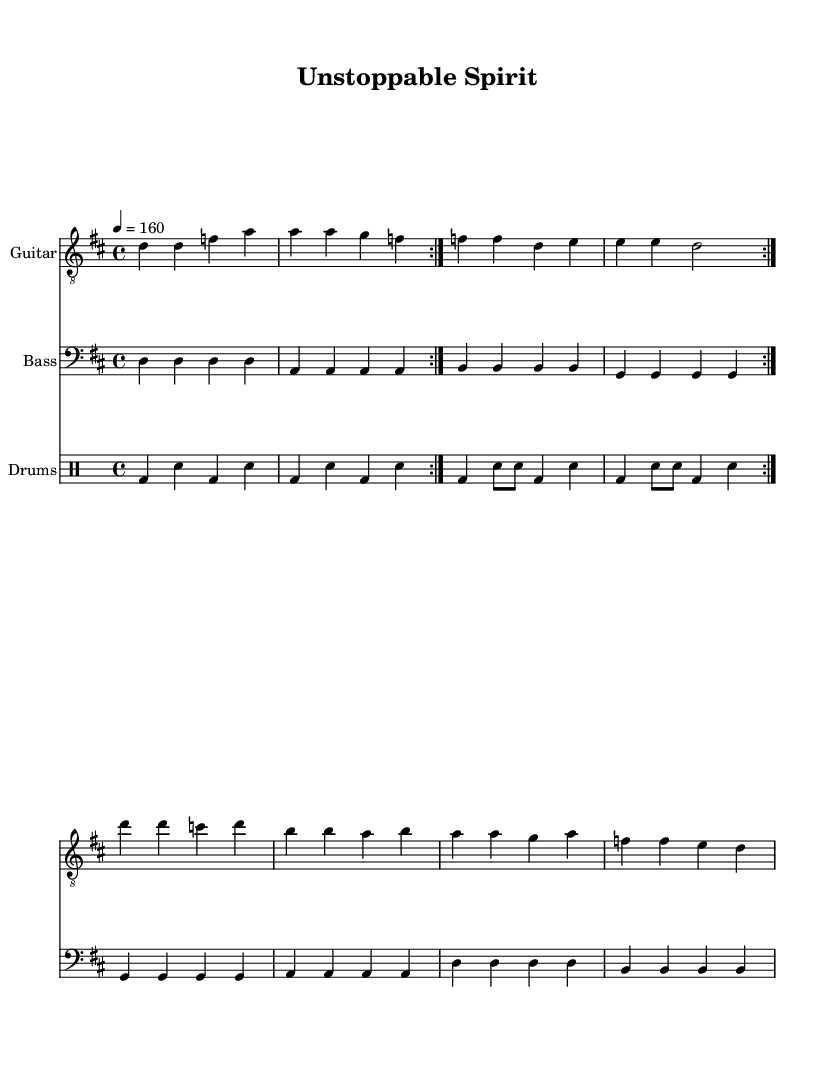What is the key signature of this music? The key signature is D major, indicated by two sharps (F# and C#).
Answer: D major What is the time signature of this music? The time signature is 4/4, meaning there are four beats in each measure and the quarter note gets one beat.
Answer: 4/4 What is the tempo marking of this music? The tempo marking indicates a tempo of 160 beats per minute, specified by the instruction "4 = 160."
Answer: 160 How many measures are repeated in the guitar part? The guitar part has two measures that are repeated twice, as indicated by the "repeat volta 2" instruction.
Answer: 2 What is the central theme expressed in the lyrics? The lyrics express resilience and strength, celebrating individuality and the ability to overcome challenges associated with chronic conditions.
Answer: Resilience What rhythmic pattern is used in the drum section? The drum section alternates between bass drum and snare, creating a steady backbeat typical of punk rock.
Answer: Alternation What does the phrase "unstoppable spirit" represent in the context of this music? The phrase embodies the idea of perseverance and strength among individuals living with chronic conditions, aligning with the upbeat nature of punk rock.
Answer: Perseverance 